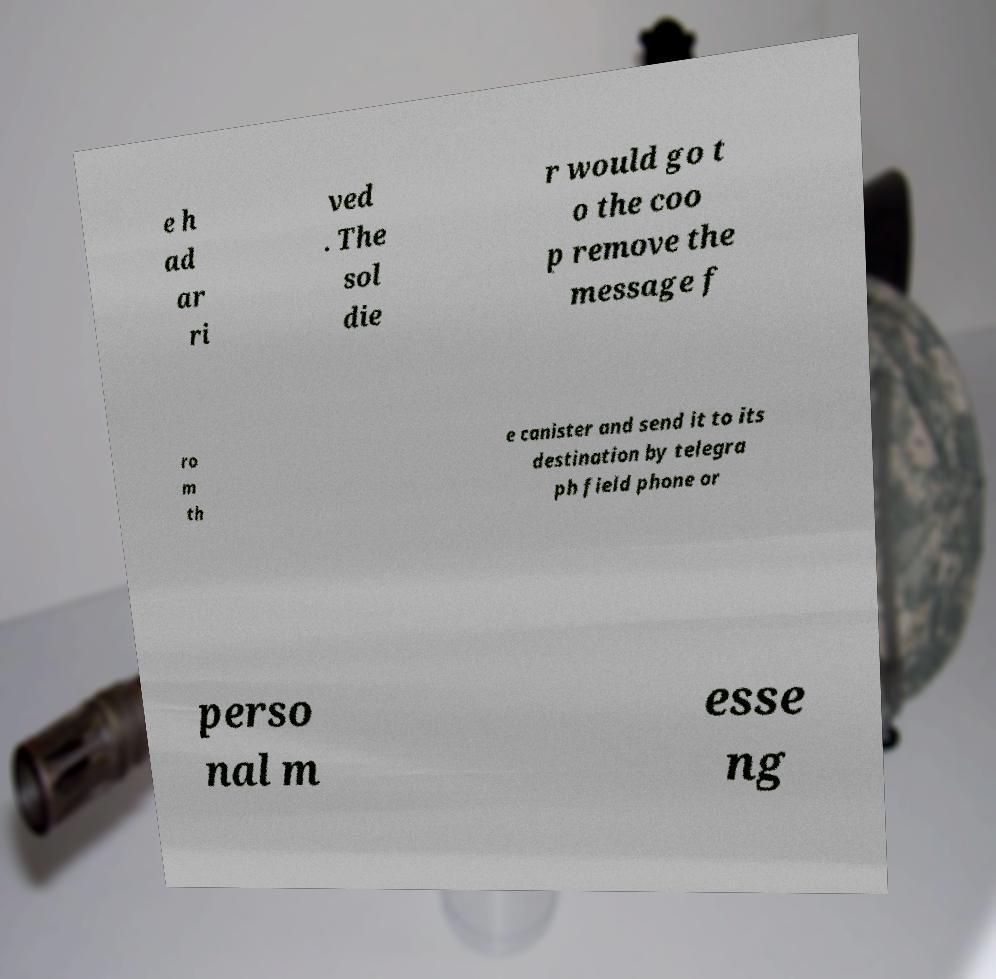Can you accurately transcribe the text from the provided image for me? e h ad ar ri ved . The sol die r would go t o the coo p remove the message f ro m th e canister and send it to its destination by telegra ph field phone or perso nal m esse ng 